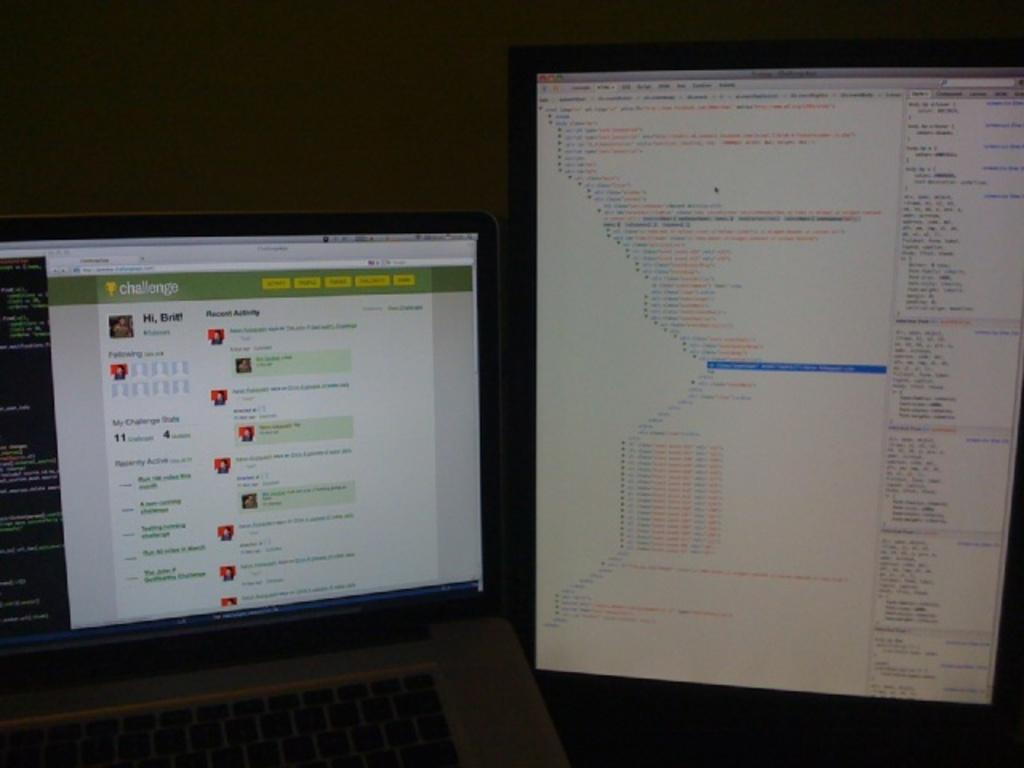<image>
Write a terse but informative summary of the picture. A computer screen on the Challenge page that says Hi, Brit! 